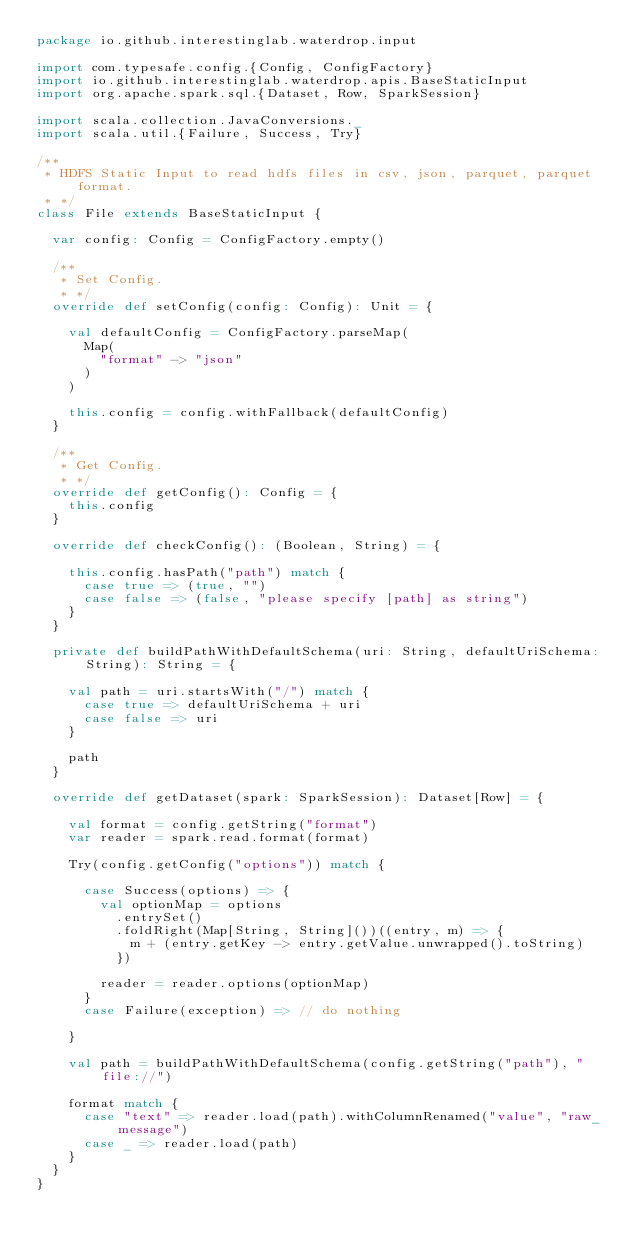Convert code to text. <code><loc_0><loc_0><loc_500><loc_500><_Scala_>package io.github.interestinglab.waterdrop.input

import com.typesafe.config.{Config, ConfigFactory}
import io.github.interestinglab.waterdrop.apis.BaseStaticInput
import org.apache.spark.sql.{Dataset, Row, SparkSession}

import scala.collection.JavaConversions._
import scala.util.{Failure, Success, Try}

/**
 * HDFS Static Input to read hdfs files in csv, json, parquet, parquet format.
 * */
class File extends BaseStaticInput {

  var config: Config = ConfigFactory.empty()

  /**
   * Set Config.
   * */
  override def setConfig(config: Config): Unit = {

    val defaultConfig = ConfigFactory.parseMap(
      Map(
        "format" -> "json"
      )
    )

    this.config = config.withFallback(defaultConfig)
  }

  /**
   * Get Config.
   * */
  override def getConfig(): Config = {
    this.config
  }

  override def checkConfig(): (Boolean, String) = {

    this.config.hasPath("path") match {
      case true => (true, "")
      case false => (false, "please specify [path] as string")
    }
  }

  private def buildPathWithDefaultSchema(uri: String, defaultUriSchema: String): String = {

    val path = uri.startsWith("/") match {
      case true => defaultUriSchema + uri
      case false => uri
    }

    path
  }

  override def getDataset(spark: SparkSession): Dataset[Row] = {

    val format = config.getString("format")
    var reader = spark.read.format(format)

    Try(config.getConfig("options")) match {

      case Success(options) => {
        val optionMap = options
          .entrySet()
          .foldRight(Map[String, String]())((entry, m) => {
            m + (entry.getKey -> entry.getValue.unwrapped().toString)
          })

        reader = reader.options(optionMap)
      }
      case Failure(exception) => // do nothing

    }

    val path = buildPathWithDefaultSchema(config.getString("path"), "file://")

    format match {
      case "text" => reader.load(path).withColumnRenamed("value", "raw_message")
      case _ => reader.load(path)
    }
  }
}
</code> 